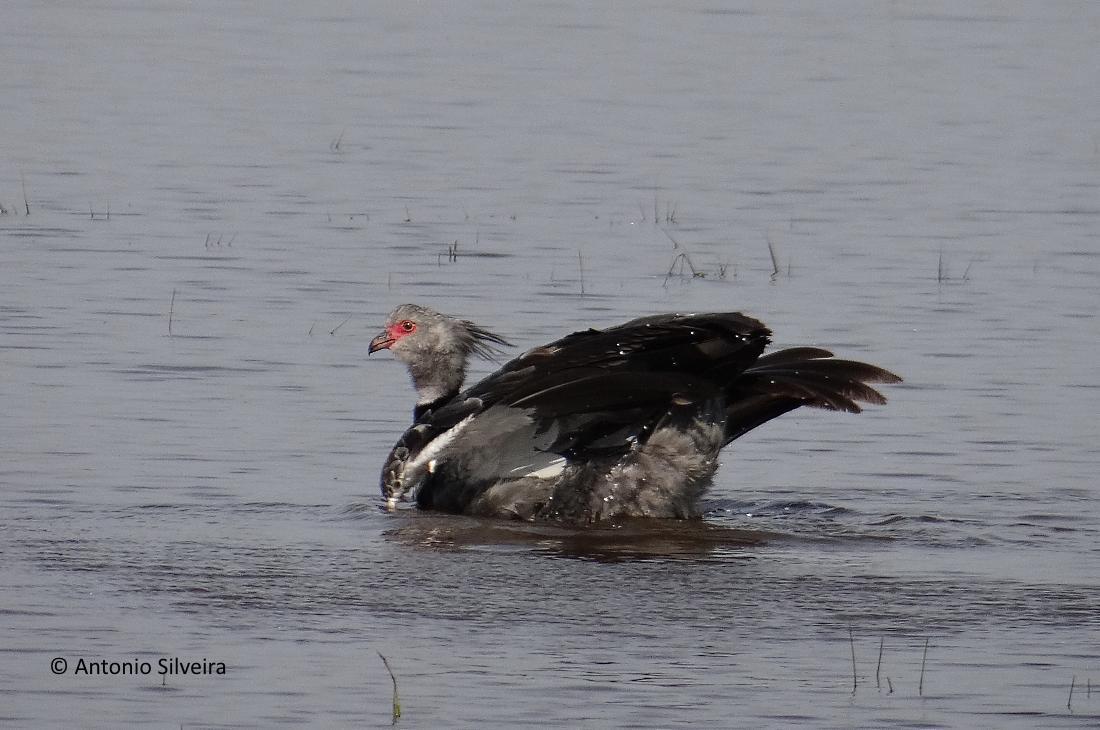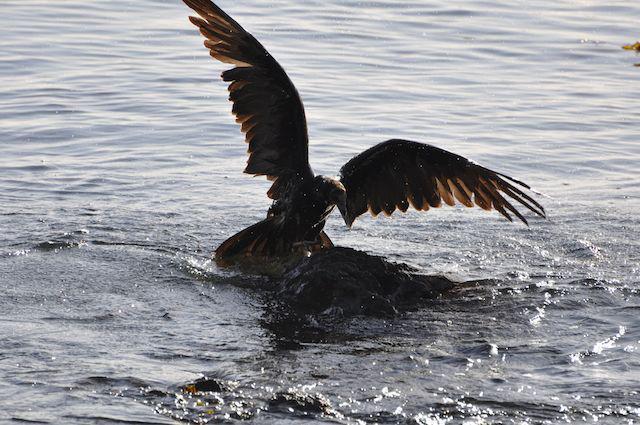The first image is the image on the left, the second image is the image on the right. Examine the images to the left and right. Is the description "There are two birds, both in water." accurate? Answer yes or no. Yes. The first image is the image on the left, the second image is the image on the right. Assess this claim about the two images: "An image shows one leftward swimming bird with wings that are not spread.". Correct or not? Answer yes or no. Yes. 